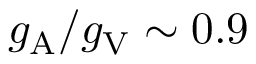Convert formula to latex. <formula><loc_0><loc_0><loc_500><loc_500>g _ { A } / g _ { V } \sim 0 . 9</formula> 